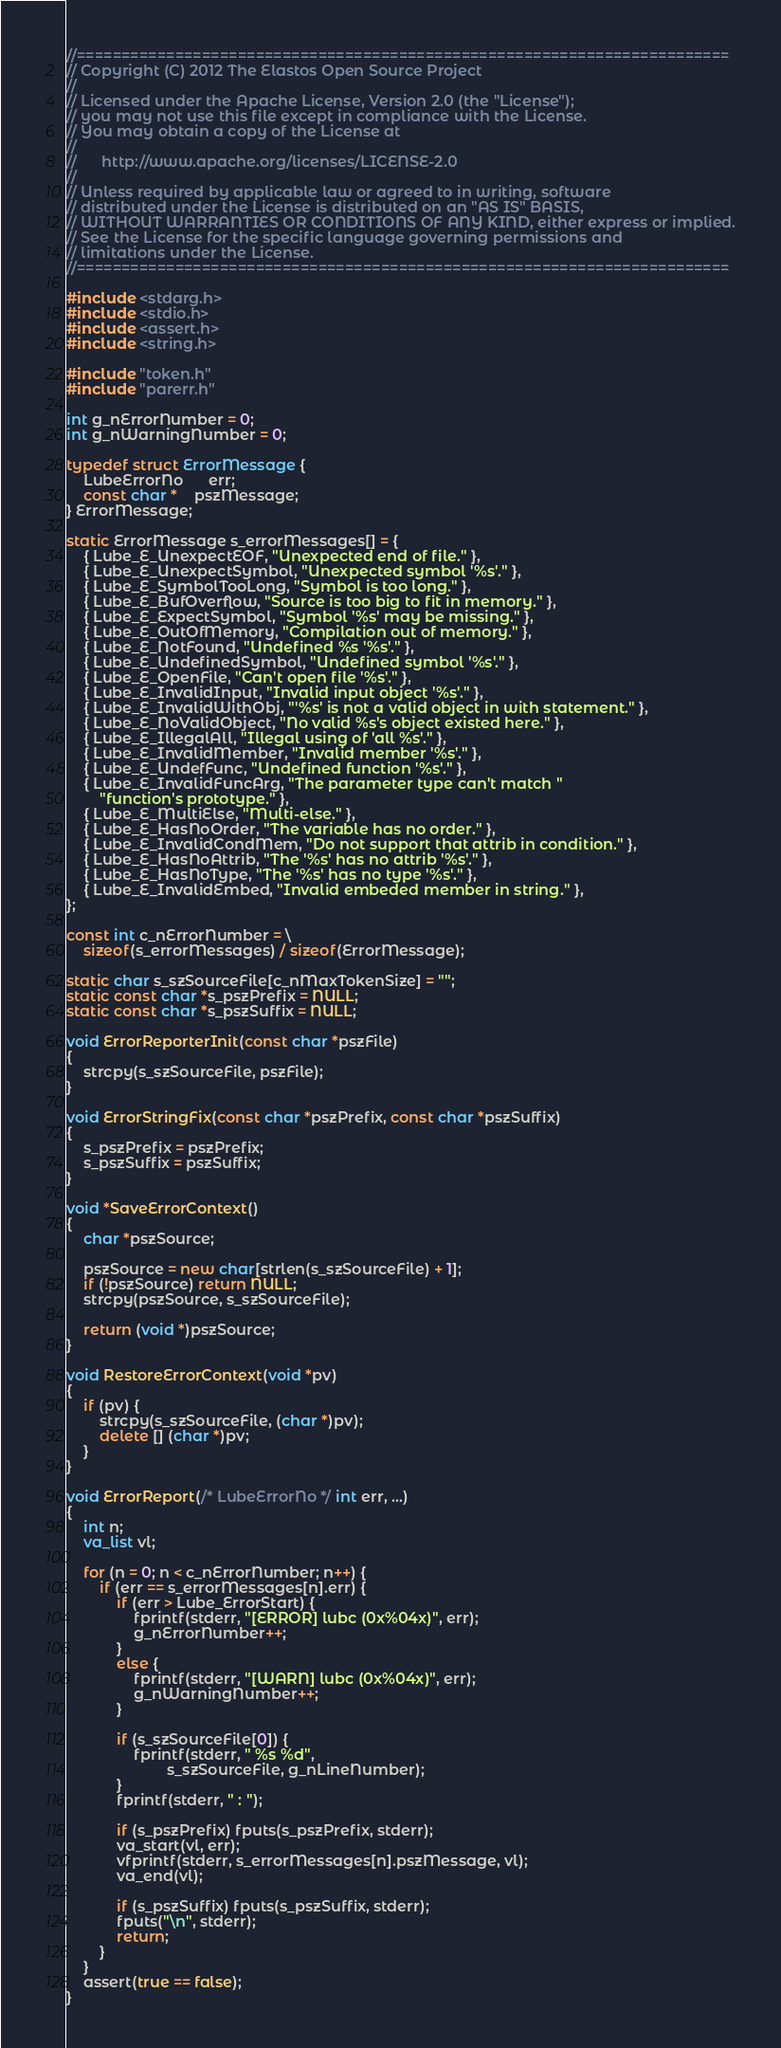Convert code to text. <code><loc_0><loc_0><loc_500><loc_500><_C++_>//=========================================================================
// Copyright (C) 2012 The Elastos Open Source Project
//
// Licensed under the Apache License, Version 2.0 (the "License");
// you may not use this file except in compliance with the License.
// You may obtain a copy of the License at
//
//      http://www.apache.org/licenses/LICENSE-2.0
//
// Unless required by applicable law or agreed to in writing, software
// distributed under the License is distributed on an "AS IS" BASIS,
// WITHOUT WARRANTIES OR CONDITIONS OF ANY KIND, either express or implied.
// See the License for the specific language governing permissions and
// limitations under the License.
//=========================================================================

#include <stdarg.h>
#include <stdio.h>
#include <assert.h>
#include <string.h>

#include "token.h"
#include "parerr.h"

int g_nErrorNumber = 0;
int g_nWarningNumber = 0;

typedef struct ErrorMessage {
    LubeErrorNo      err;
    const char *    pszMessage;
} ErrorMessage;

static ErrorMessage s_errorMessages[] = {
    { Lube_E_UnexpectEOF, "Unexpected end of file." },
    { Lube_E_UnexpectSymbol, "Unexpected symbol '%s'." },
    { Lube_E_SymbolTooLong, "Symbol is too long." },
    { Lube_E_BufOverflow, "Source is too big to fit in memory." },
    { Lube_E_ExpectSymbol, "Symbol '%s' may be missing." },
    { Lube_E_OutOfMemory, "Compilation out of memory." },
    { Lube_E_NotFound, "Undefined %s '%s'." },
    { Lube_E_UndefinedSymbol, "Undefined symbol '%s'." },
    { Lube_E_OpenFile, "Can't open file '%s'." },
    { Lube_E_InvalidInput, "Invalid input object '%s'." },
    { Lube_E_InvalidWithObj, "'%s' is not a valid object in with statement." },
    { Lube_E_NoValidObject, "No valid %s's object existed here." },
    { Lube_E_IllegalAll, "Illegal using of 'all %s'." },
    { Lube_E_InvalidMember, "Invalid member '%s'." },
    { Lube_E_UndefFunc, "Undefined function '%s'." },
    { Lube_E_InvalidFuncArg, "The parameter type can't match "
        "function's prototype." },
    { Lube_E_MultiElse, "Multi-else." },
    { Lube_E_HasNoOrder, "The variable has no order." },
    { Lube_E_InvalidCondMem, "Do not support that attrib in condition." },
    { Lube_E_HasNoAttrib, "The '%s' has no attrib '%s'." },
    { Lube_E_HasNoType, "The '%s' has no type '%s'." },
    { Lube_E_InvalidEmbed, "Invalid embeded member in string." },
};

const int c_nErrorNumber = \
    sizeof(s_errorMessages) / sizeof(ErrorMessage);

static char s_szSourceFile[c_nMaxTokenSize] = "";
static const char *s_pszPrefix = NULL;
static const char *s_pszSuffix = NULL;

void ErrorReporterInit(const char *pszFile)
{
    strcpy(s_szSourceFile, pszFile);
}

void ErrorStringFix(const char *pszPrefix, const char *pszSuffix)
{
    s_pszPrefix = pszPrefix;
    s_pszSuffix = pszSuffix;
}

void *SaveErrorContext()
{
    char *pszSource;

    pszSource = new char[strlen(s_szSourceFile) + 1];
    if (!pszSource) return NULL;
    strcpy(pszSource, s_szSourceFile);

    return (void *)pszSource;
}

void RestoreErrorContext(void *pv)
{
    if (pv) {
        strcpy(s_szSourceFile, (char *)pv);
        delete [] (char *)pv;
    }
}

void ErrorReport(/* LubeErrorNo */ int err, ...)
{
    int n;
    va_list vl;

    for (n = 0; n < c_nErrorNumber; n++) {
        if (err == s_errorMessages[n].err) {
            if (err > Lube_ErrorStart) {
                fprintf(stderr, "[ERROR] lubc (0x%04x)", err);
                g_nErrorNumber++;
            }
            else {
                fprintf(stderr, "[WARN] lubc (0x%04x)", err);
                g_nWarningNumber++;
            }

            if (s_szSourceFile[0]) {
                fprintf(stderr, " %s %d",
                        s_szSourceFile, g_nLineNumber);
            }
            fprintf(stderr, " : ");

            if (s_pszPrefix) fputs(s_pszPrefix, stderr);
            va_start(vl, err);
            vfprintf(stderr, s_errorMessages[n].pszMessage, vl);
            va_end(vl);

            if (s_pszSuffix) fputs(s_pszSuffix, stderr);
            fputs("\n", stderr);
            return;
        }
    }
    assert(true == false);
}
</code> 